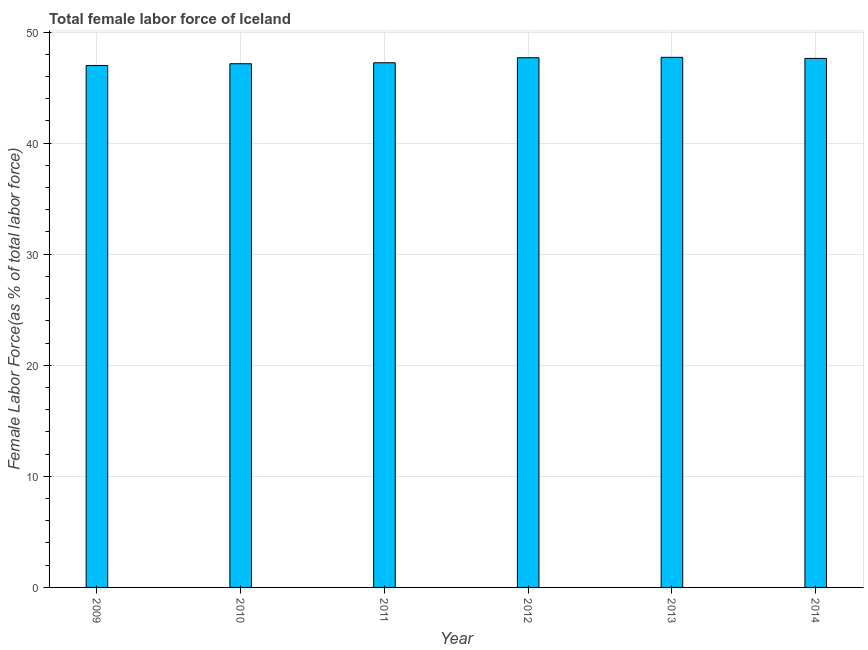Does the graph contain any zero values?
Provide a succinct answer. No. Does the graph contain grids?
Your response must be concise. Yes. What is the title of the graph?
Give a very brief answer. Total female labor force of Iceland. What is the label or title of the Y-axis?
Keep it short and to the point. Female Labor Force(as % of total labor force). What is the total female labor force in 2009?
Make the answer very short. 46.99. Across all years, what is the maximum total female labor force?
Your answer should be very brief. 47.72. Across all years, what is the minimum total female labor force?
Provide a short and direct response. 46.99. In which year was the total female labor force maximum?
Ensure brevity in your answer.  2013. What is the sum of the total female labor force?
Your answer should be very brief. 284.41. What is the difference between the total female labor force in 2010 and 2014?
Ensure brevity in your answer.  -0.48. What is the average total female labor force per year?
Your answer should be very brief. 47.4. What is the median total female labor force?
Your answer should be very brief. 47.43. Do a majority of the years between 2014 and 2012 (inclusive) have total female labor force greater than 30 %?
Provide a short and direct response. Yes. Is the difference between the total female labor force in 2013 and 2014 greater than the difference between any two years?
Your response must be concise. No. What is the difference between the highest and the second highest total female labor force?
Your response must be concise. 0.04. Is the sum of the total female labor force in 2013 and 2014 greater than the maximum total female labor force across all years?
Keep it short and to the point. Yes. What is the difference between the highest and the lowest total female labor force?
Make the answer very short. 0.73. In how many years, is the total female labor force greater than the average total female labor force taken over all years?
Your response must be concise. 3. How many bars are there?
Offer a very short reply. 6. Are all the bars in the graph horizontal?
Offer a terse response. No. What is the Female Labor Force(as % of total labor force) in 2009?
Your response must be concise. 46.99. What is the Female Labor Force(as % of total labor force) in 2010?
Provide a short and direct response. 47.15. What is the Female Labor Force(as % of total labor force) of 2011?
Your answer should be very brief. 47.23. What is the Female Labor Force(as % of total labor force) in 2012?
Offer a terse response. 47.69. What is the Female Labor Force(as % of total labor force) in 2013?
Your response must be concise. 47.72. What is the Female Labor Force(as % of total labor force) of 2014?
Provide a succinct answer. 47.63. What is the difference between the Female Labor Force(as % of total labor force) in 2009 and 2010?
Ensure brevity in your answer.  -0.16. What is the difference between the Female Labor Force(as % of total labor force) in 2009 and 2011?
Your answer should be compact. -0.24. What is the difference between the Female Labor Force(as % of total labor force) in 2009 and 2012?
Your answer should be compact. -0.7. What is the difference between the Female Labor Force(as % of total labor force) in 2009 and 2013?
Make the answer very short. -0.73. What is the difference between the Female Labor Force(as % of total labor force) in 2009 and 2014?
Your response must be concise. -0.64. What is the difference between the Female Labor Force(as % of total labor force) in 2010 and 2011?
Provide a short and direct response. -0.09. What is the difference between the Female Labor Force(as % of total labor force) in 2010 and 2012?
Give a very brief answer. -0.54. What is the difference between the Female Labor Force(as % of total labor force) in 2010 and 2013?
Keep it short and to the point. -0.58. What is the difference between the Female Labor Force(as % of total labor force) in 2010 and 2014?
Offer a terse response. -0.48. What is the difference between the Female Labor Force(as % of total labor force) in 2011 and 2012?
Provide a succinct answer. -0.45. What is the difference between the Female Labor Force(as % of total labor force) in 2011 and 2013?
Offer a terse response. -0.49. What is the difference between the Female Labor Force(as % of total labor force) in 2011 and 2014?
Offer a very short reply. -0.39. What is the difference between the Female Labor Force(as % of total labor force) in 2012 and 2013?
Ensure brevity in your answer.  -0.04. What is the difference between the Female Labor Force(as % of total labor force) in 2012 and 2014?
Offer a very short reply. 0.06. What is the difference between the Female Labor Force(as % of total labor force) in 2013 and 2014?
Your response must be concise. 0.1. What is the ratio of the Female Labor Force(as % of total labor force) in 2009 to that in 2010?
Offer a very short reply. 1. What is the ratio of the Female Labor Force(as % of total labor force) in 2009 to that in 2011?
Your answer should be very brief. 0.99. What is the ratio of the Female Labor Force(as % of total labor force) in 2009 to that in 2012?
Offer a terse response. 0.98. What is the ratio of the Female Labor Force(as % of total labor force) in 2010 to that in 2011?
Offer a terse response. 1. What is the ratio of the Female Labor Force(as % of total labor force) in 2010 to that in 2012?
Provide a succinct answer. 0.99. What is the ratio of the Female Labor Force(as % of total labor force) in 2010 to that in 2013?
Offer a terse response. 0.99. What is the ratio of the Female Labor Force(as % of total labor force) in 2011 to that in 2014?
Offer a very short reply. 0.99. 